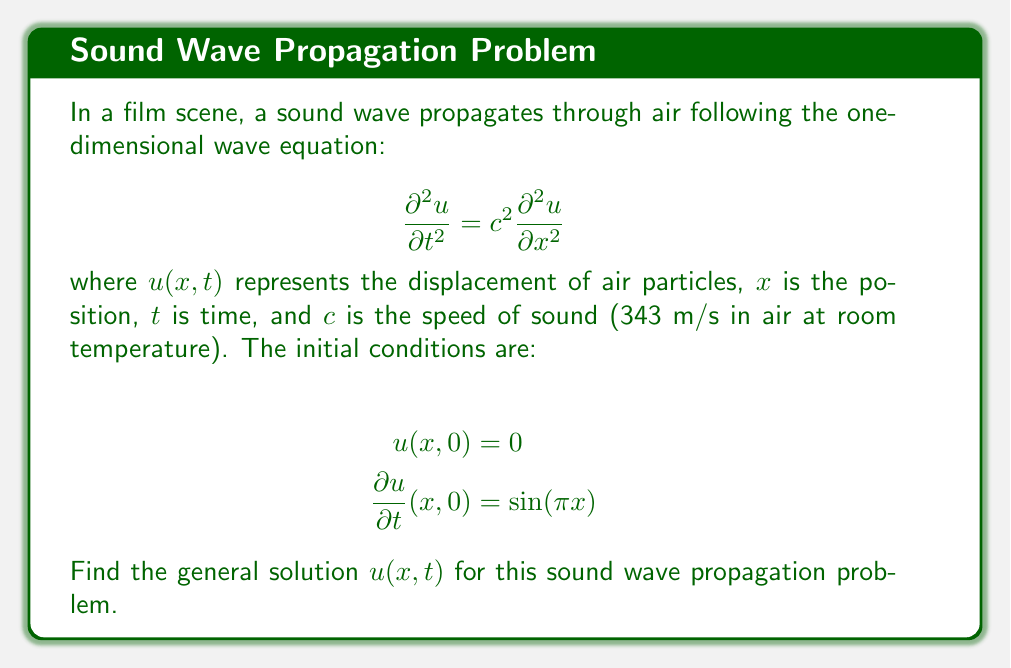Give your solution to this math problem. To solve this problem, we'll use the method of separation of variables:

1) Assume the solution has the form $u(x,t) = X(x)T(t)$.

2) Substitute this into the wave equation:
   $$X(x)T''(t) = c^2X''(x)T(t)$$

3) Divide both sides by $c^2X(x)T(t)$:
   $$\frac{T''(t)}{c^2T(t)} = \frac{X''(x)}{X(x)} = -k^2$$
   where $-k^2$ is a separation constant.

4) This gives us two ordinary differential equations:
   $$T''(t) + c^2k^2T(t) = 0$$
   $$X''(x) + k^2X(x) = 0$$

5) The general solutions to these equations are:
   $$T(t) = A\cos(ckt) + B\sin(ckt)$$
   $$X(x) = C\cos(kx) + D\sin(kx)$$

6) The general solution is thus:
   $$u(x,t) = [C\cos(kx) + D\sin(kx)][A\cos(ckt) + B\sin(ckt)]$$

7) Apply the initial condition $u(x,0) = 0$:
   $$u(x,0) = [C\cos(kx) + D\sin(kx)]A = 0$$
   This implies $A = 0$.

8) Apply the second initial condition:
   $$\frac{\partial u}{\partial t}(x,0) = [C\cos(kx) + D\sin(kx)]Bck = \sin(\pi x)$$

9) This implies:
   $$C = 0, D = 1, k = \pi, Bc\pi = 1$$

10) Therefore, $B = \frac{1}{c\pi}$

Thus, the general solution is:
$$u(x,t) = \frac{1}{c\pi}\sin(\pi x)\sin(c\pi t)$$
Answer: $$u(x,t) = \frac{1}{c\pi}\sin(\pi x)\sin(c\pi t)$$ 